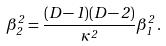Convert formula to latex. <formula><loc_0><loc_0><loc_500><loc_500>\beta _ { 2 } ^ { 2 } = \frac { ( D - 1 ) ( D - 2 ) } { \kappa ^ { 2 } } \beta _ { 1 } ^ { 2 } \, .</formula> 